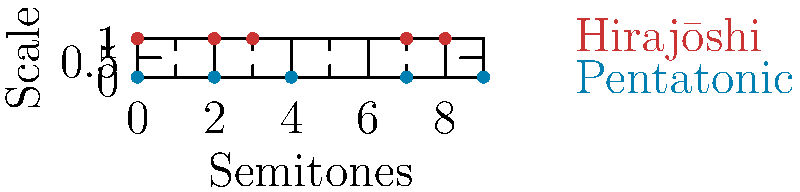As a music producer familiar with Japanese scales, consider the symmetry groups of the traditional pentatonic and Hirajōshi scales shown in the diagram. If we define a transformation $T$ that shifts each note by 7 semitones (perfect fifth), what is the order of the symmetry group generated by $T$ for the Hirajōshi scale? To solve this problem, we need to follow these steps:

1. Understand the Hirajōshi scale:
   The Hirajōshi scale consists of the notes: 0, 2, 3, 7, 8 (in semitones from the root).

2. Apply the transformation $T$ (shift by 7 semitones):
   $T(0) = 7$, $T(2) = 9$, $T(3) = 10$, $T(7) = 2$, $T(8) = 3$

3. Observe that $T(7) = 2$ and $T(8) = 3$ are already in the scale.
   We need to continue applying $T$ until we return to the original scale.

4. Apply $T$ again:
   $T^2(0) = 2$, $T^2(2) = 9$, $T^2(3) = 10$, $T^2(7) = 9$, $T^2(8) = 10$

5. Apply $T$ once more:
   $T^3(0) = 9$, $T^3(2) = 4$, $T^3(3) = 5$, $T^3(7) = 4$, $T^3(8) = 5$

6. Apply $T$ again:
   $T^4(0) = 4$, $T^4(2) = 11$, $T^4(3) = 0$, $T^4(7) = 11$, $T^4(8) = 0$

7. One more application of $T$:
   $T^5(0) = 11$, $T^5(2) = 6$, $T^5(3) = 7$, $T^5(7) = 6$, $T^5(8) = 7$

8. Final application of $T$:
   $T^6(0) = 6$, $T^6(2) = 1$, $T^6(3) = 2$, $T^6(7) = 1$, $T^6(8) = 2$

9. Observe that $T^6$ brings us back to a transposition of the original scale (all notes shifted by 6 semitones).

10. Therefore, the order of the symmetry group generated by $T$ is 6.
Answer: 6 